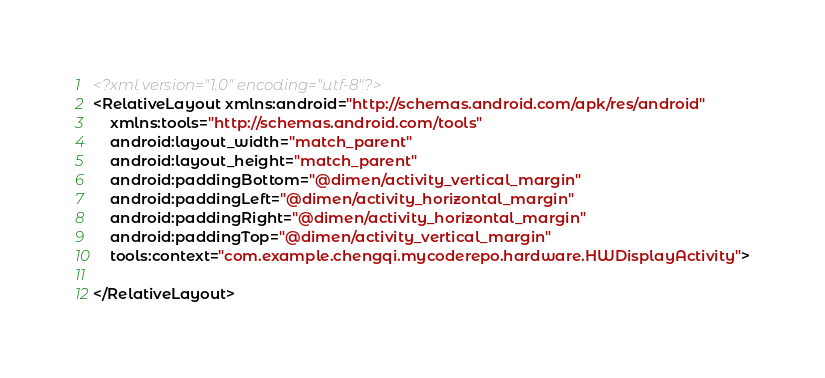<code> <loc_0><loc_0><loc_500><loc_500><_XML_><?xml version="1.0" encoding="utf-8"?>
<RelativeLayout xmlns:android="http://schemas.android.com/apk/res/android"
    xmlns:tools="http://schemas.android.com/tools"
    android:layout_width="match_parent"
    android:layout_height="match_parent"
    android:paddingBottom="@dimen/activity_vertical_margin"
    android:paddingLeft="@dimen/activity_horizontal_margin"
    android:paddingRight="@dimen/activity_horizontal_margin"
    android:paddingTop="@dimen/activity_vertical_margin"
    tools:context="com.example.chengqi.mycoderepo.hardware.HWDisplayActivity">

</RelativeLayout>
</code> 